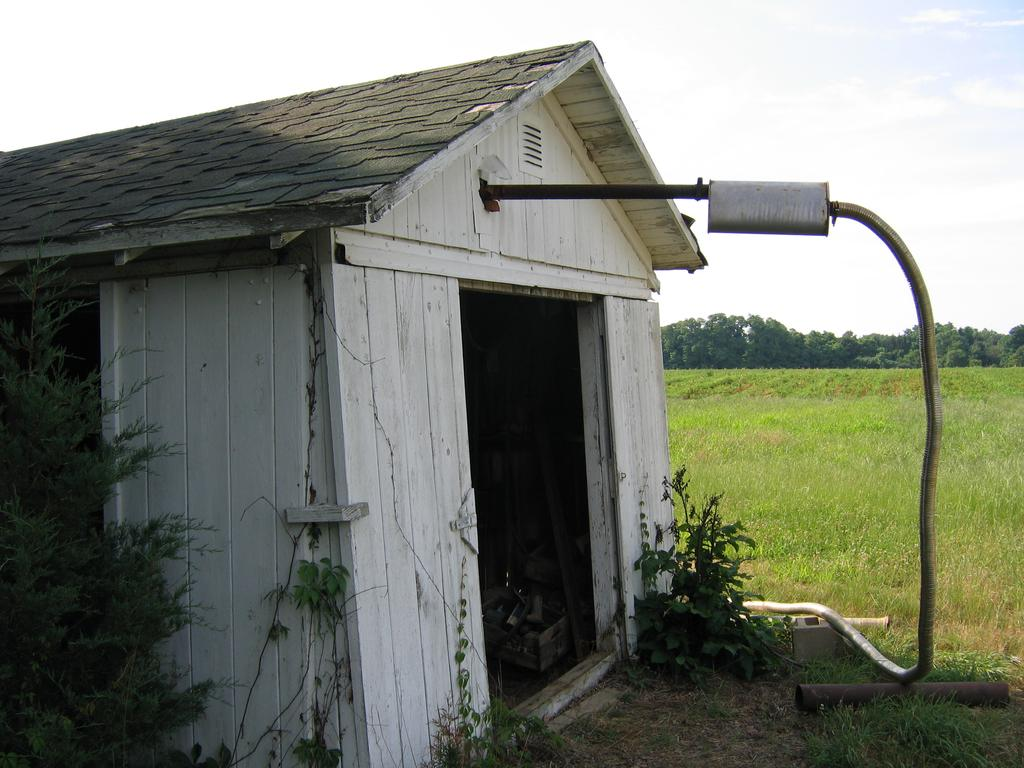What type of structure is in the picture? There is a house in the picture. What is connected to the house? There is a pipe attached to the house. What can be seen in the background of the picture? There is grass, trees, and the sky visible in the background. Where are the plants located in the picture? The plants are on the left side of the picture. What type of bridge can be seen connecting the house to the scene in the image? There is no bridge present in the image; it only features a house, a pipe, and plants. Who is the guide in the image? There is no guide present in the image. 